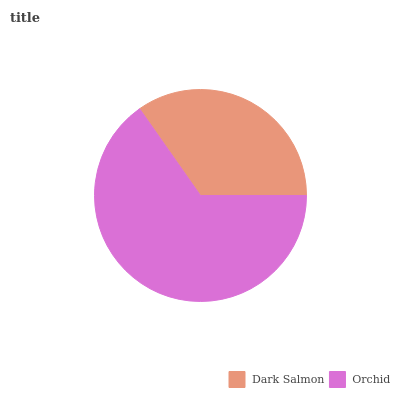Is Dark Salmon the minimum?
Answer yes or no. Yes. Is Orchid the maximum?
Answer yes or no. Yes. Is Orchid the minimum?
Answer yes or no. No. Is Orchid greater than Dark Salmon?
Answer yes or no. Yes. Is Dark Salmon less than Orchid?
Answer yes or no. Yes. Is Dark Salmon greater than Orchid?
Answer yes or no. No. Is Orchid less than Dark Salmon?
Answer yes or no. No. Is Orchid the high median?
Answer yes or no. Yes. Is Dark Salmon the low median?
Answer yes or no. Yes. Is Dark Salmon the high median?
Answer yes or no. No. Is Orchid the low median?
Answer yes or no. No. 